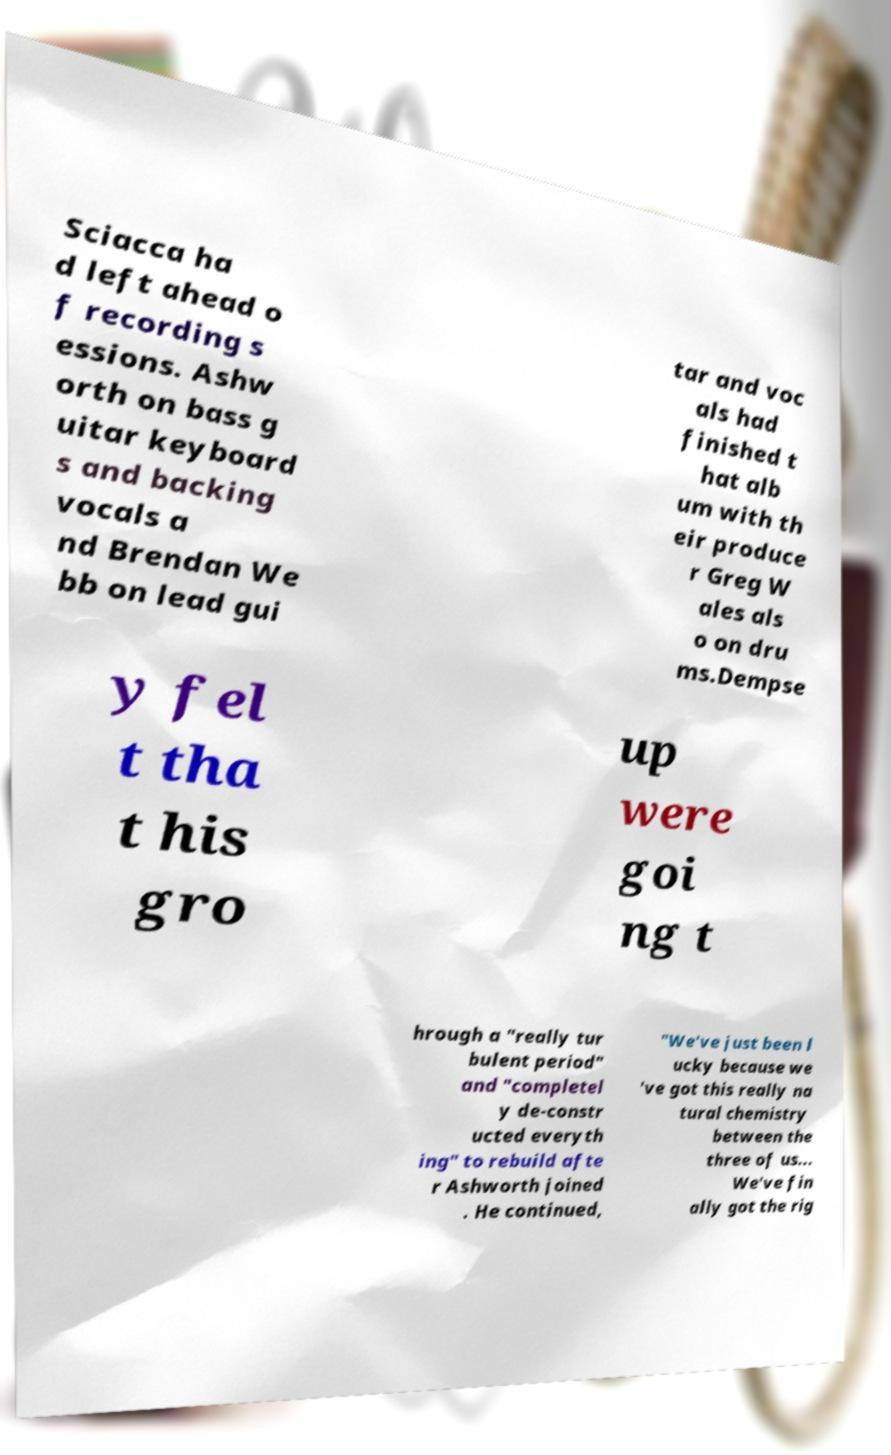I need the written content from this picture converted into text. Can you do that? Sciacca ha d left ahead o f recording s essions. Ashw orth on bass g uitar keyboard s and backing vocals a nd Brendan We bb on lead gui tar and voc als had finished t hat alb um with th eir produce r Greg W ales als o on dru ms.Dempse y fel t tha t his gro up were goi ng t hrough a "really tur bulent period" and "completel y de-constr ucted everyth ing" to rebuild afte r Ashworth joined . He continued, "We've just been l ucky because we 've got this really na tural chemistry between the three of us... We've fin ally got the rig 